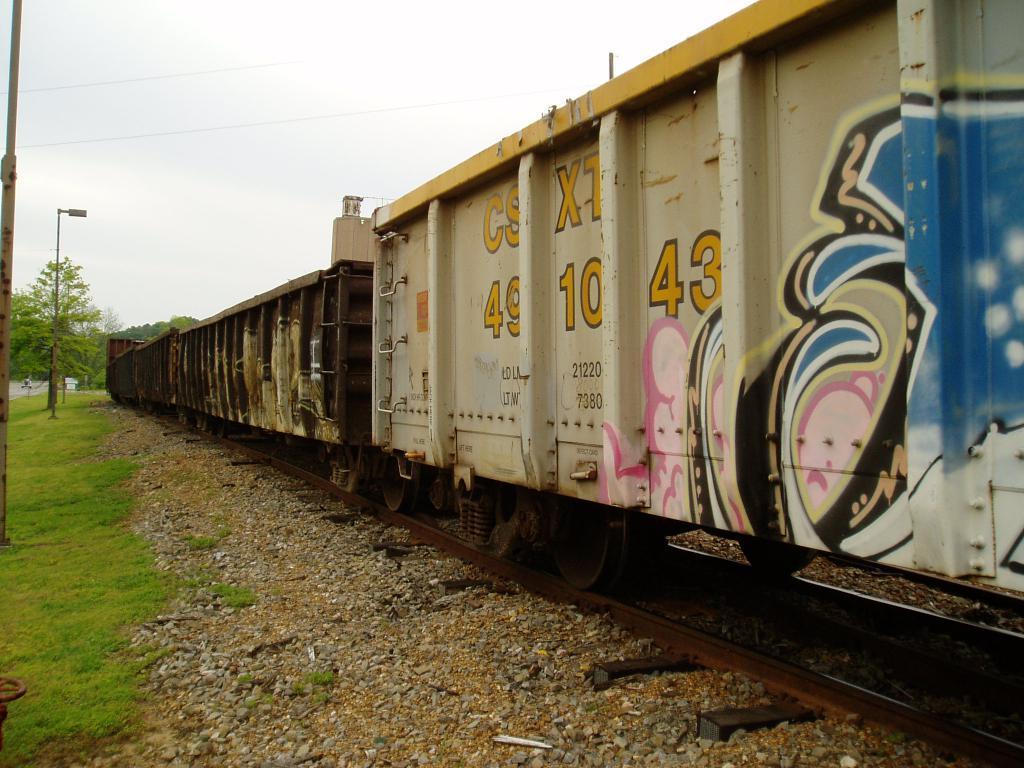Can you describe this image briefly? In this image there is a goods locomotive train on the tracks, beside the train there is grass on the surface and there are trees and lamp posts. 